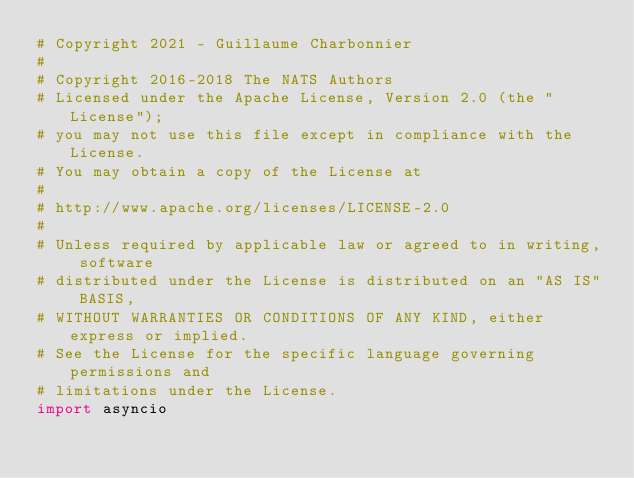Convert code to text. <code><loc_0><loc_0><loc_500><loc_500><_Python_># Copyright 2021 - Guillaume Charbonnier
#
# Copyright 2016-2018 The NATS Authors
# Licensed under the Apache License, Version 2.0 (the "License");
# you may not use this file except in compliance with the License.
# You may obtain a copy of the License at
#
# http://www.apache.org/licenses/LICENSE-2.0
#
# Unless required by applicable law or agreed to in writing, software
# distributed under the License is distributed on an "AS IS" BASIS,
# WITHOUT WARRANTIES OR CONDITIONS OF ANY KIND, either express or implied.
# See the License for the specific language governing permissions and
# limitations under the License.
import asyncio</code> 